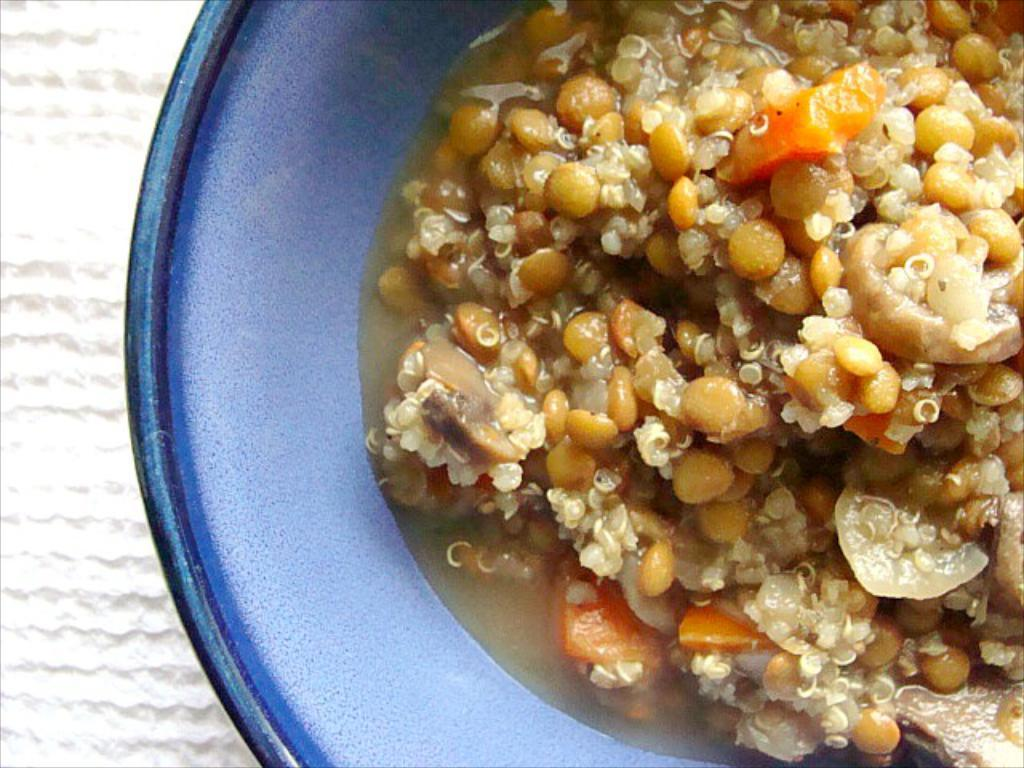What is in the bowl that is visible in the image? There is food in a bowl in the image. What can be seen on the left side of the image? There is a white color background on the left side of the image. What type of crown is worn by the spider on the right side of the image? There is no spider or crown present in the image; it only features a bowl of food and a white color background on the left side. 